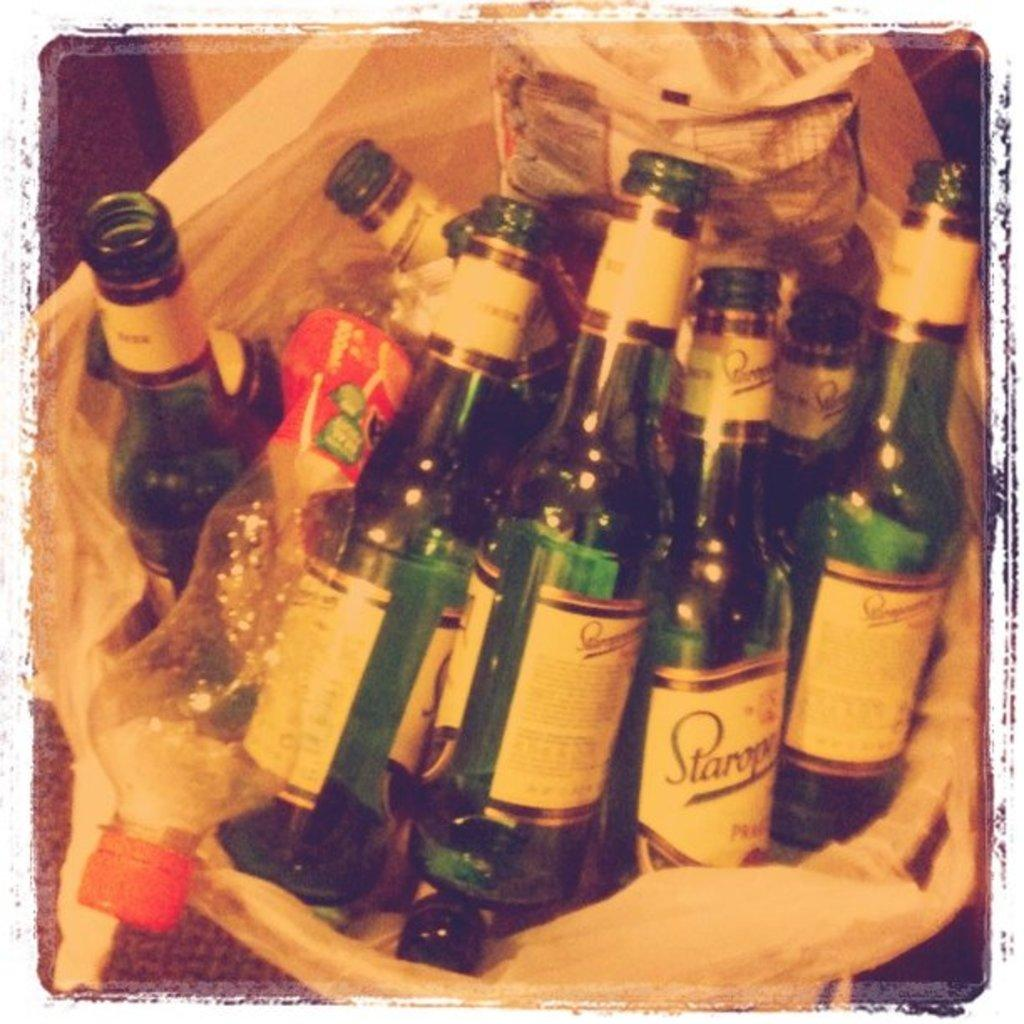What type of beverage containers are present in the image? There are wine bottles in the image. What is the color of the cover in the image? The cover in the image is white. What is being concealed under the white cover? There are other unspecified items under the white cover. Can you see a deer in the image? No, there is no deer present in the image. What type of sound is being made by the airplane in the image? There is no airplane present in the image, so it is not possible to determine the sound it might be making. 